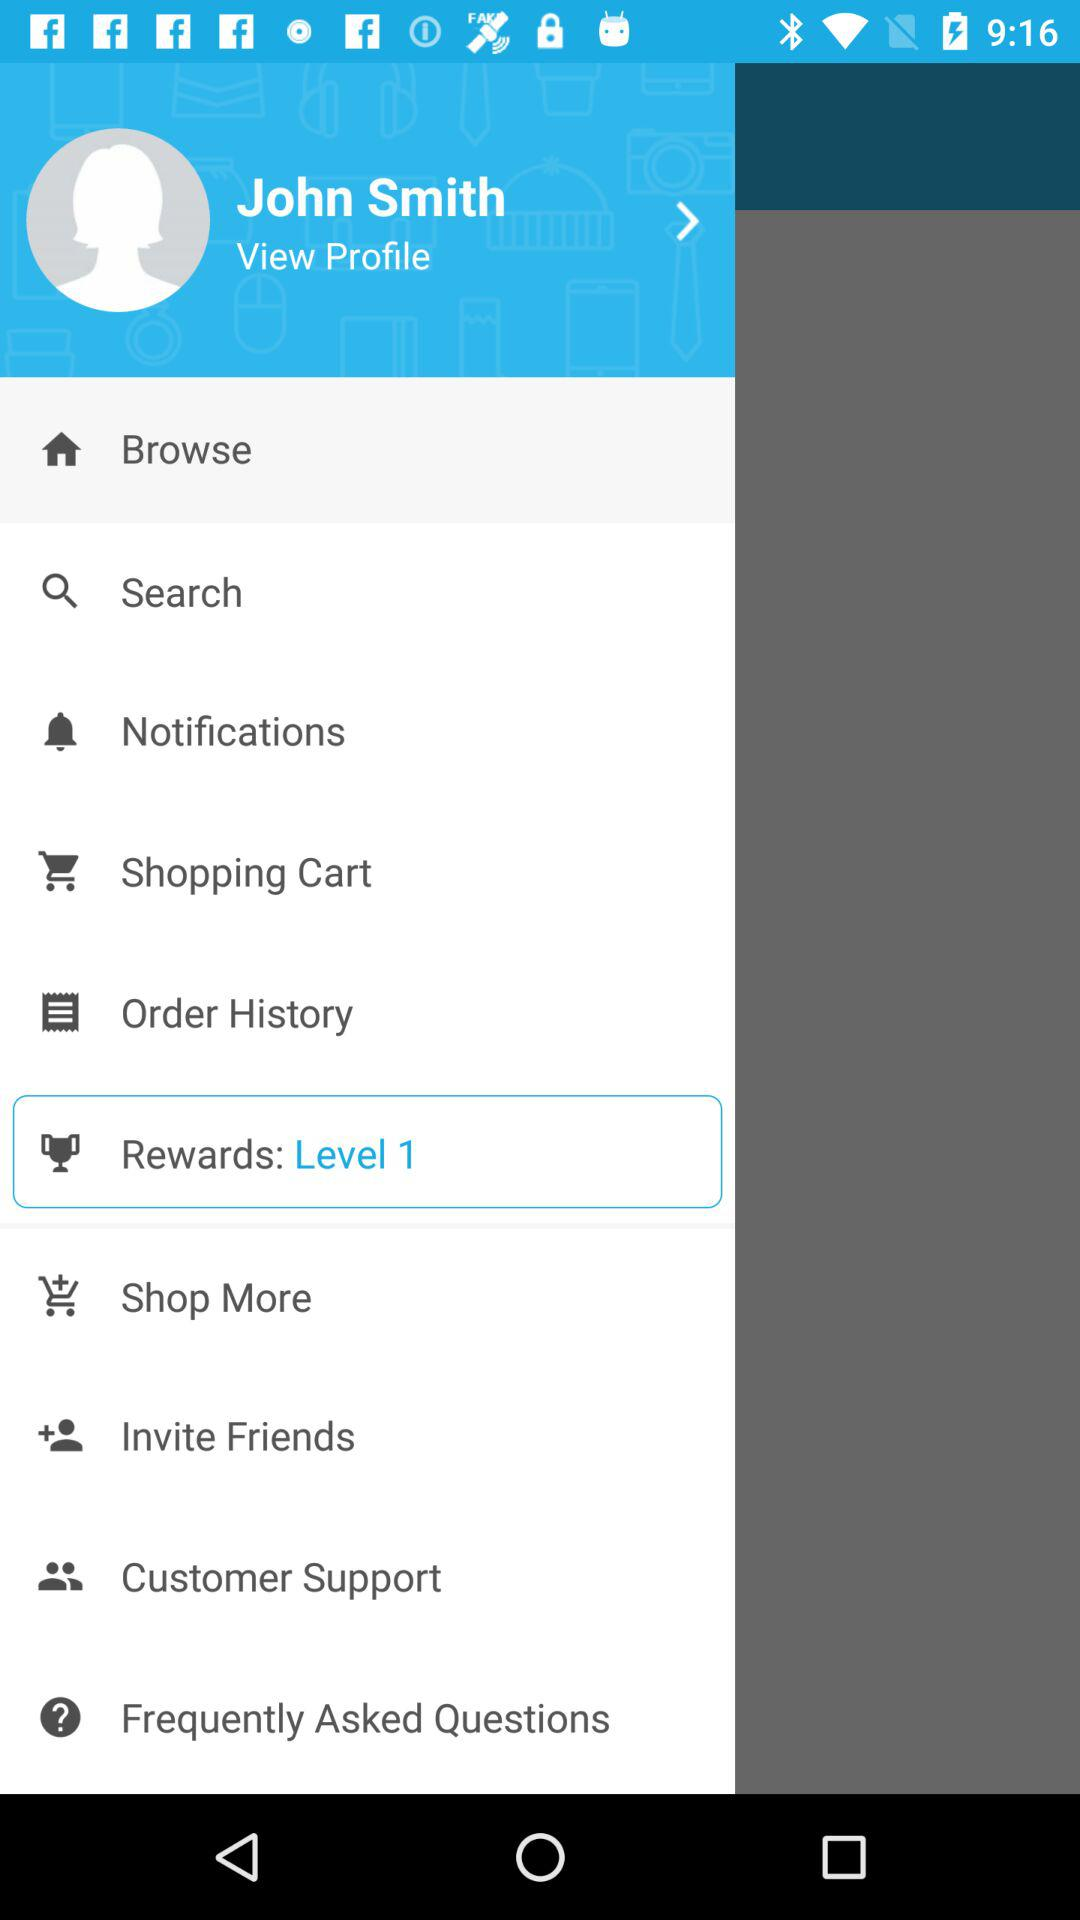What "Rewards" is selected? The selected reward is "Level 1". 